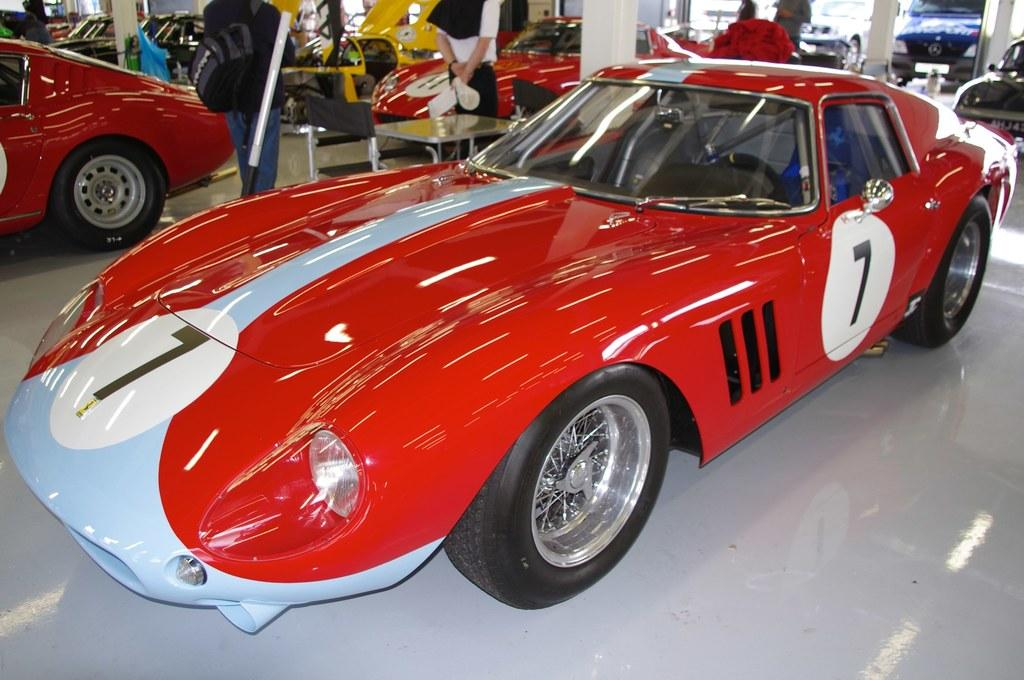What can be seen in large numbers in the image? There are many vehicles in the image. Are there any people present in the image? Yes, there are people standing in the image. What type of furniture is visible in the image? There is a table in the image. What architectural feature can be seen in the image? There are pillars in the image. What type of crook is trying to negotiate peace with the bear in the image? There is no crook, peace negotiation, or bear present in the image. 